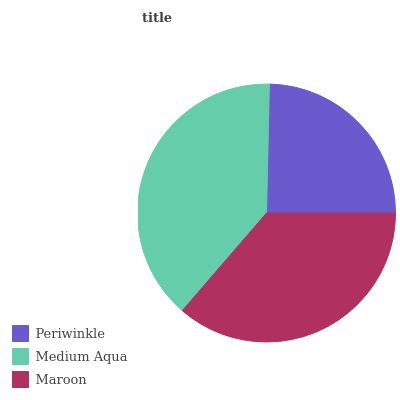Is Periwinkle the minimum?
Answer yes or no. Yes. Is Medium Aqua the maximum?
Answer yes or no. Yes. Is Maroon the minimum?
Answer yes or no. No. Is Maroon the maximum?
Answer yes or no. No. Is Medium Aqua greater than Maroon?
Answer yes or no. Yes. Is Maroon less than Medium Aqua?
Answer yes or no. Yes. Is Maroon greater than Medium Aqua?
Answer yes or no. No. Is Medium Aqua less than Maroon?
Answer yes or no. No. Is Maroon the high median?
Answer yes or no. Yes. Is Maroon the low median?
Answer yes or no. Yes. Is Periwinkle the high median?
Answer yes or no. No. Is Medium Aqua the low median?
Answer yes or no. No. 